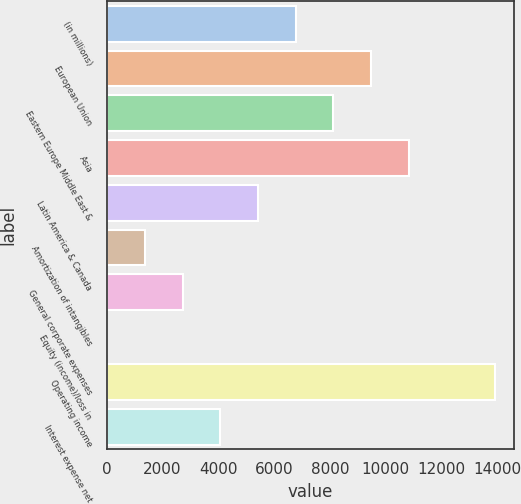<chart> <loc_0><loc_0><loc_500><loc_500><bar_chart><fcel>(in millions)<fcel>European Union<fcel>Eastern Europe Middle East &<fcel>Asia<fcel>Latin America & Canada<fcel>Amortization of intangibles<fcel>General corporate expenses<fcel>Equity (income)/loss in<fcel>Operating income<fcel>Interest expense net<nl><fcel>6768.5<fcel>9467.1<fcel>8117.8<fcel>10816.4<fcel>5419.2<fcel>1371.3<fcel>2720.6<fcel>22<fcel>13891.3<fcel>4069.9<nl></chart> 